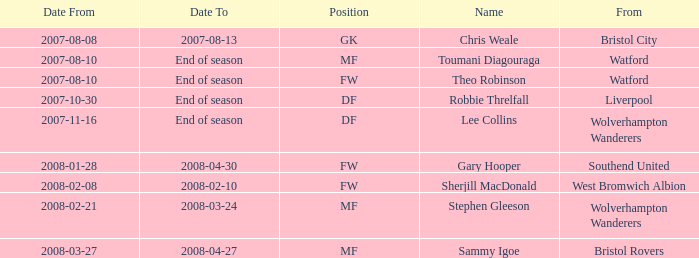When did toumani diagouraga, a midfielder, start playing? 2007-08-10. 